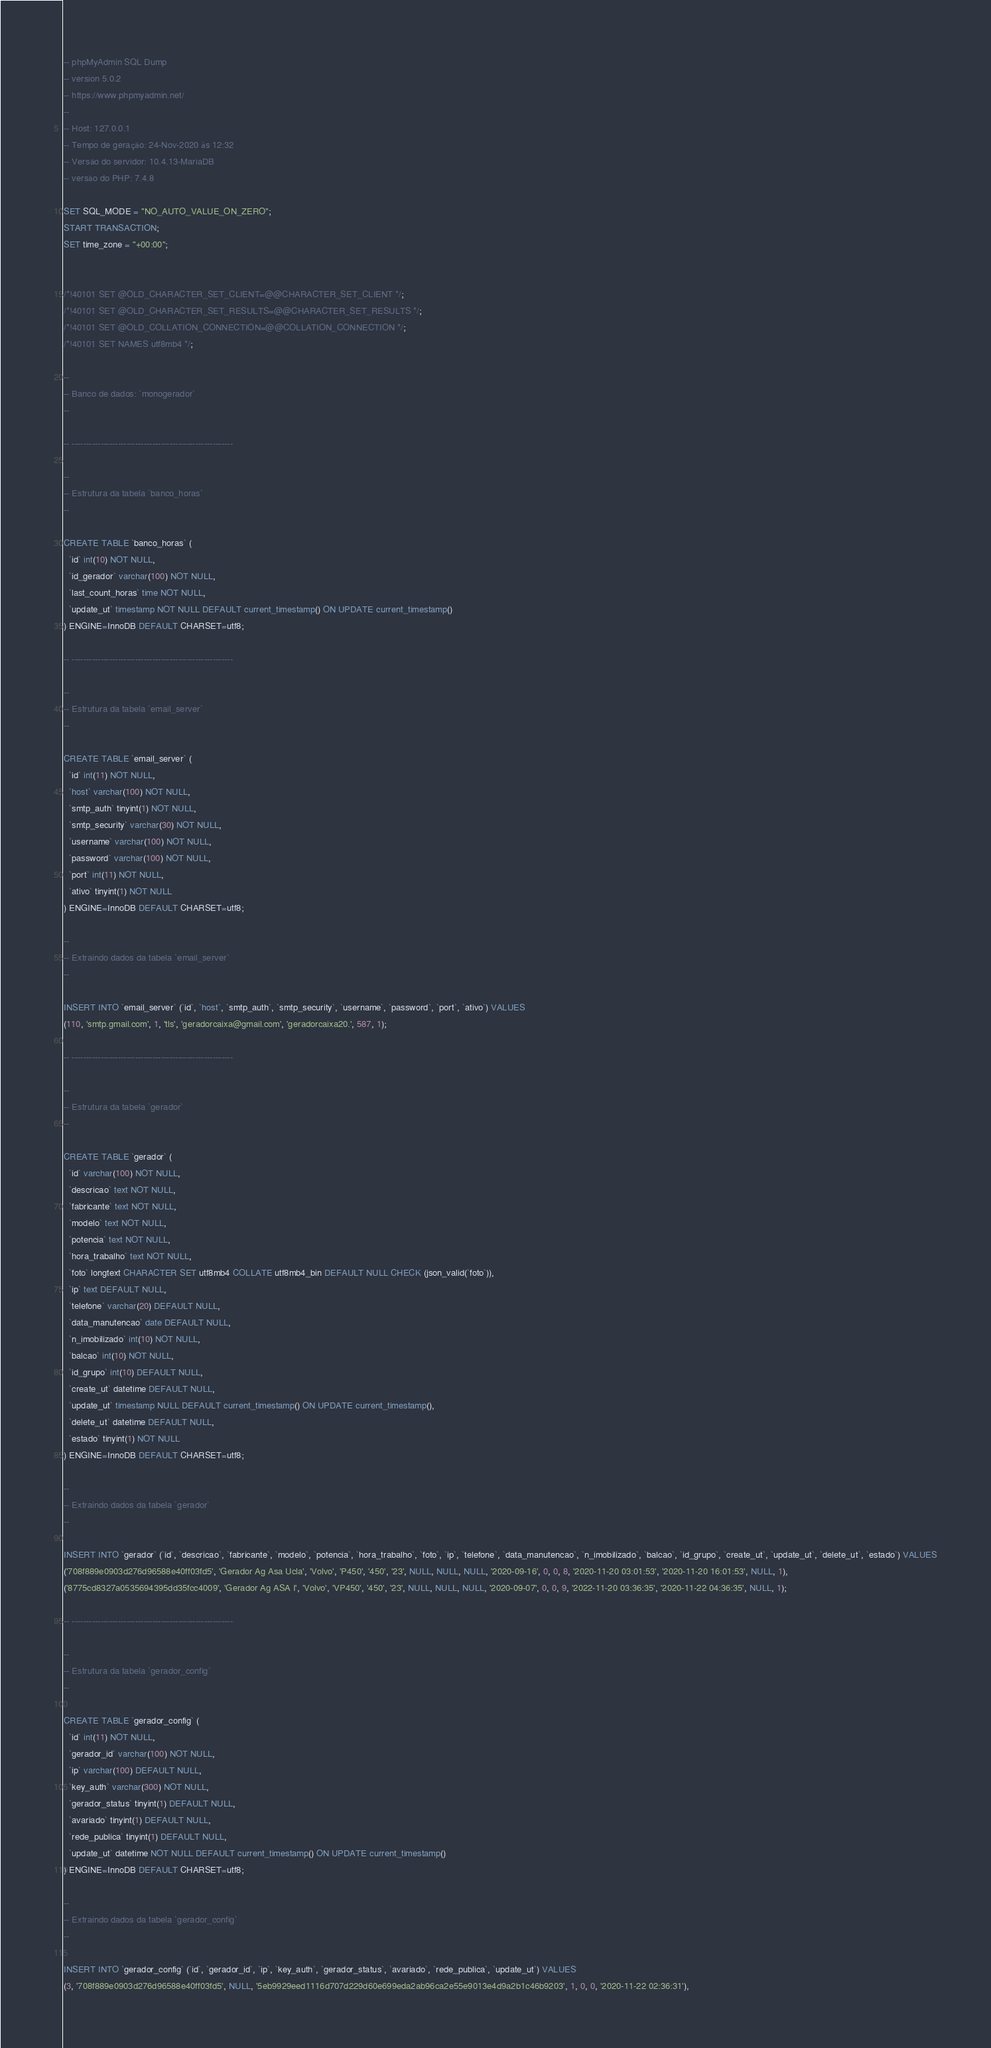<code> <loc_0><loc_0><loc_500><loc_500><_SQL_>-- phpMyAdmin SQL Dump
-- version 5.0.2
-- https://www.phpmyadmin.net/
--
-- Host: 127.0.0.1
-- Tempo de geração: 24-Nov-2020 às 12:32
-- Versão do servidor: 10.4.13-MariaDB
-- versão do PHP: 7.4.8

SET SQL_MODE = "NO_AUTO_VALUE_ON_ZERO";
START TRANSACTION;
SET time_zone = "+00:00";


/*!40101 SET @OLD_CHARACTER_SET_CLIENT=@@CHARACTER_SET_CLIENT */;
/*!40101 SET @OLD_CHARACTER_SET_RESULTS=@@CHARACTER_SET_RESULTS */;
/*!40101 SET @OLD_COLLATION_CONNECTION=@@COLLATION_CONNECTION */;
/*!40101 SET NAMES utf8mb4 */;

--
-- Banco de dados: `monogerador`
--

-- --------------------------------------------------------

--
-- Estrutura da tabela `banco_horas`
--

CREATE TABLE `banco_horas` (
  `id` int(10) NOT NULL,
  `id_gerador` varchar(100) NOT NULL,
  `last_count_horas` time NOT NULL,
  `update_ut` timestamp NOT NULL DEFAULT current_timestamp() ON UPDATE current_timestamp()
) ENGINE=InnoDB DEFAULT CHARSET=utf8;

-- --------------------------------------------------------

--
-- Estrutura da tabela `email_server`
--

CREATE TABLE `email_server` (
  `id` int(11) NOT NULL,
  `host` varchar(100) NOT NULL,
  `smtp_auth` tinyint(1) NOT NULL,
  `smtp_security` varchar(30) NOT NULL,
  `username` varchar(100) NOT NULL,
  `password` varchar(100) NOT NULL,
  `port` int(11) NOT NULL,
  `ativo` tinyint(1) NOT NULL
) ENGINE=InnoDB DEFAULT CHARSET=utf8;

--
-- Extraindo dados da tabela `email_server`
--

INSERT INTO `email_server` (`id`, `host`, `smtp_auth`, `smtp_security`, `username`, `password`, `port`, `ativo`) VALUES
(110, 'smtp.gmail.com', 1, 'tls', 'geradorcaixa@gmail.com', 'geradorcaixa20.', 587, 1);

-- --------------------------------------------------------

--
-- Estrutura da tabela `gerador`
--

CREATE TABLE `gerador` (
  `id` varchar(100) NOT NULL,
  `descricao` text NOT NULL,
  `fabricante` text NOT NULL,
  `modelo` text NOT NULL,
  `potencia` text NOT NULL,
  `hora_trabalho` text NOT NULL,
  `foto` longtext CHARACTER SET utf8mb4 COLLATE utf8mb4_bin DEFAULT NULL CHECK (json_valid(`foto`)),
  `ip` text DEFAULT NULL,
  `telefone` varchar(20) DEFAULT NULL,
  `data_manutencao` date DEFAULT NULL,
  `n_imobilizado` int(10) NOT NULL,
  `balcao` int(10) NOT NULL,
  `id_grupo` int(10) DEFAULT NULL,
  `create_ut` datetime DEFAULT NULL,
  `update_ut` timestamp NULL DEFAULT current_timestamp() ON UPDATE current_timestamp(),
  `delete_ut` datetime DEFAULT NULL,
  `estado` tinyint(1) NOT NULL
) ENGINE=InnoDB DEFAULT CHARSET=utf8;

--
-- Extraindo dados da tabela `gerador`
--

INSERT INTO `gerador` (`id`, `descricao`, `fabricante`, `modelo`, `potencia`, `hora_trabalho`, `foto`, `ip`, `telefone`, `data_manutencao`, `n_imobilizado`, `balcao`, `id_grupo`, `create_ut`, `update_ut`, `delete_ut`, `estado`) VALUES
('708f889e0903d276d96588e40ff03fd5', 'Gerador Ag Asa Ucla', 'Volvo', 'P450', '450', '23', NULL, NULL, NULL, '2020-09-16', 0, 0, 8, '2020-11-20 03:01:53', '2020-11-20 16:01:53', NULL, 1),
('8775cd8327a0535694395dd35fcc4009', 'Gerador Ag ASA I', 'Volvo', 'VP450', '450', '23', NULL, NULL, NULL, '2020-09-07', 0, 0, 9, '2022-11-20 03:36:35', '2020-11-22 04:36:35', NULL, 1);

-- --------------------------------------------------------

--
-- Estrutura da tabela `gerador_config`
--

CREATE TABLE `gerador_config` (
  `id` int(11) NOT NULL,
  `gerador_id` varchar(100) NOT NULL,
  `ip` varchar(100) DEFAULT NULL,
  `key_auth` varchar(300) NOT NULL,
  `gerador_status` tinyint(1) DEFAULT NULL,
  `avariado` tinyint(1) DEFAULT NULL,
  `rede_publica` tinyint(1) DEFAULT NULL,
  `update_ut` datetime NOT NULL DEFAULT current_timestamp() ON UPDATE current_timestamp()
) ENGINE=InnoDB DEFAULT CHARSET=utf8;

--
-- Extraindo dados da tabela `gerador_config`
--

INSERT INTO `gerador_config` (`id`, `gerador_id`, `ip`, `key_auth`, `gerador_status`, `avariado`, `rede_publica`, `update_ut`) VALUES
(3, '708f889e0903d276d96588e40ff03fd5', NULL, '5eb9929eed1116d707d229d60e699eda2ab96ca2e55e9013e4d9a2b1c46b9203', 1, 0, 0, '2020-11-22 02:36:31'),</code> 